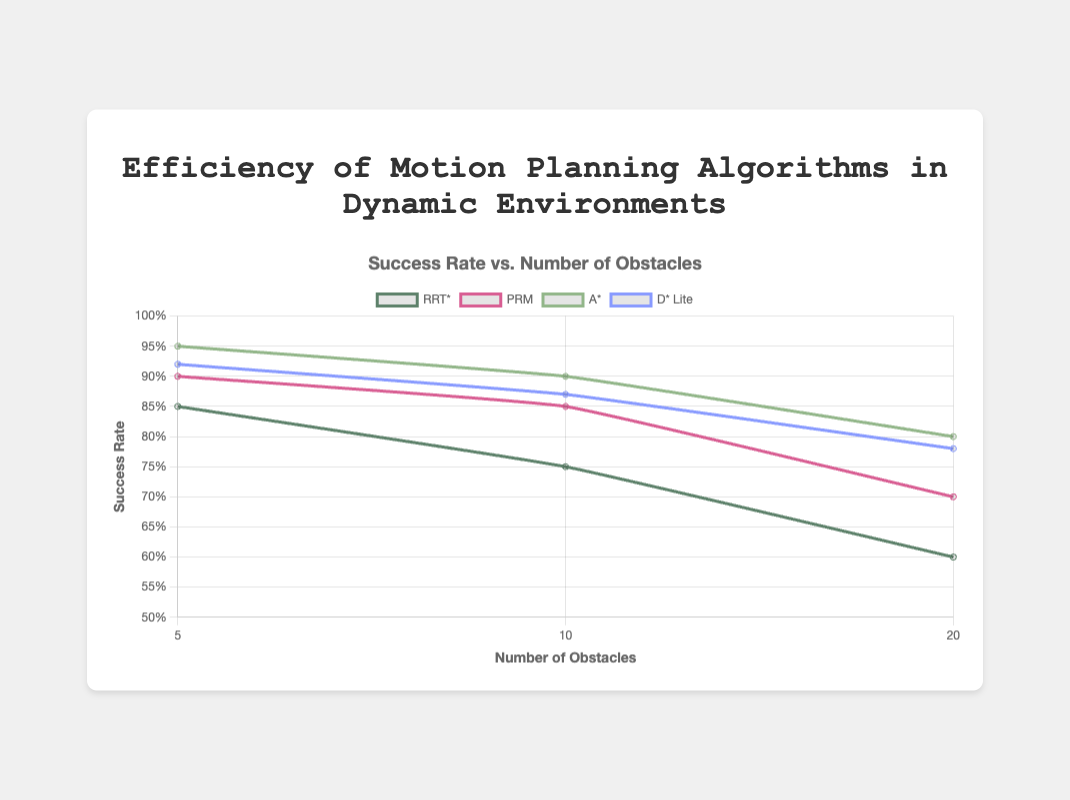What is the success rate of the RRT* algorithm with 20 obstacles? Looking at the figure, find the line corresponding to the RRT* algorithm, then locate the point where the x-axis value is 20. The y-value at this point represents the success rate.
Answer: 0.6 Which algorithm has the highest success rate with 5 obstacles? Compare the y-values of all the algorithms at the x-axis value of 5. The algorithm with the highest y-value is the one with the highest success rate at 5 obstacles.
Answer: A* How does the success rate of PRM with 10 obstacles compare to D* Lite with 10 obstacles? Identify the points for PRM and D* Lite on the x-axis at value 10. Compare their y-values to determine which success rate is higher.
Answer: PRM has a higher success rate Which algorithm shows the least decrease in success rate as the number of obstacles increases from 5 to 20? Calculate the difference in success rates for each algorithm between 5 and 20 obstacles. The algorithm with the smallest decrease in success rate is the one that is least affected by an increase in obstacles.
Answer: D* Lite What's the difference in success rate between PRM and A* for 20 obstacles? Locate the points for PRM and A* at the x-axis value of 20. Subtract the success rate value of A* from that of PRM.
Answer: -0.1 Which algorithm takes the longest average time with 10 obstacles? Locate the average time values for each algorithm at 10 obstacles and identify the highest value.
Answer: A* For the RRT* algorithm, what is the average success rate across all obstacle numbers? Add the success rates of RRT* for 5, 10, and 20 obstacles and divide by 3.
Answer: 0.73 Compare the success rates of A* and D* Lite for 5 obstacles. Which one is higher and by how much? Find the success rates of A* and D* Lite at the x-axis value of 5. Subtract the success rate of D* Lite from that of A* to find the difference.
Answer: A* is higher by 0.03 For the PRM algorithm, what is the percentage increase in average time from 5 to 20 obstacles? Subtract the average time for 5 obstacles from the average time for 20 obstacles, divide by the average time for 5 obstacles, and multiply by 100 to get the percentage.
Answer: 100% Which algorithm generally performs better at higher obstacle numbers (20 obstacles) in terms of success rate? Compare the y-values (success rates) of all algorithms at the x-axis value of 20. The algorithm with the highest y-value performs better at higher obstacle numbers.
Answer: A* 